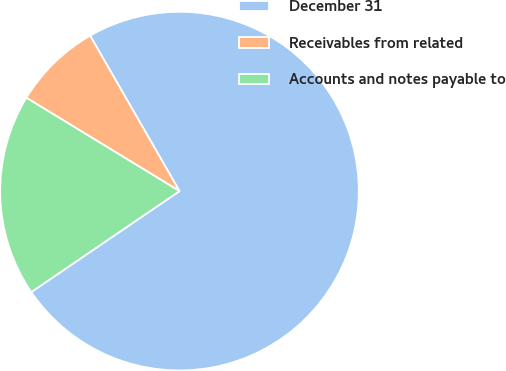<chart> <loc_0><loc_0><loc_500><loc_500><pie_chart><fcel>December 31<fcel>Receivables from related<fcel>Accounts and notes payable to<nl><fcel>73.79%<fcel>7.98%<fcel>18.23%<nl></chart> 